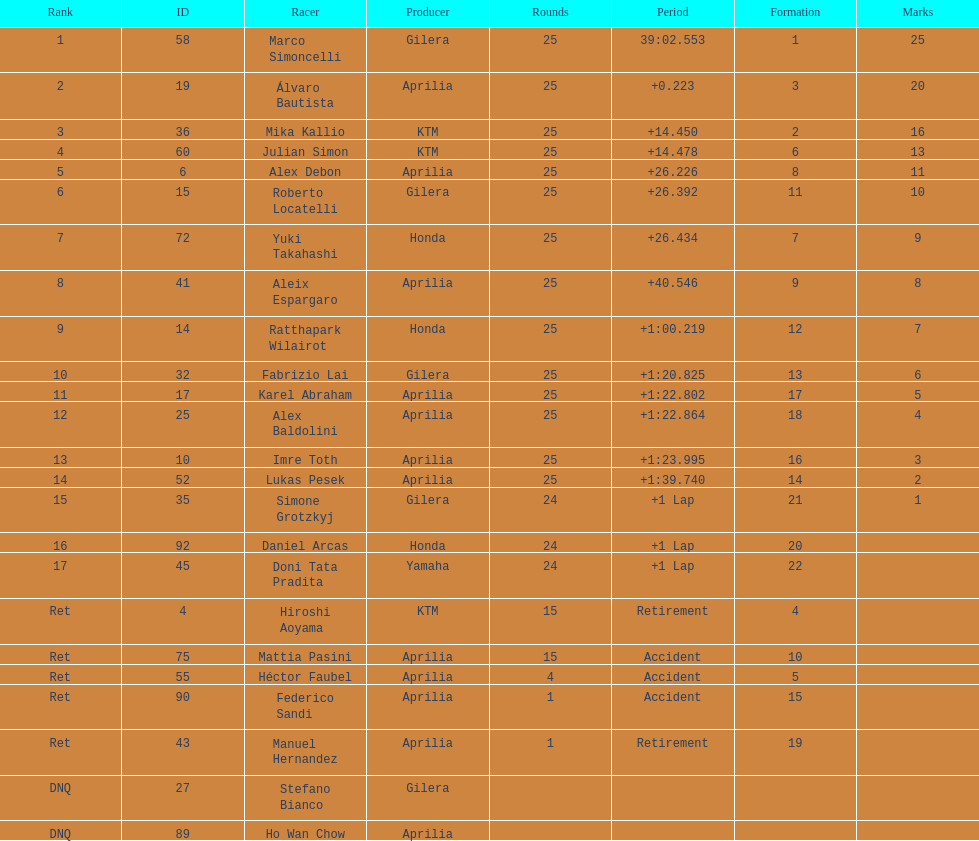The total amount of riders who did not qualify 2. 